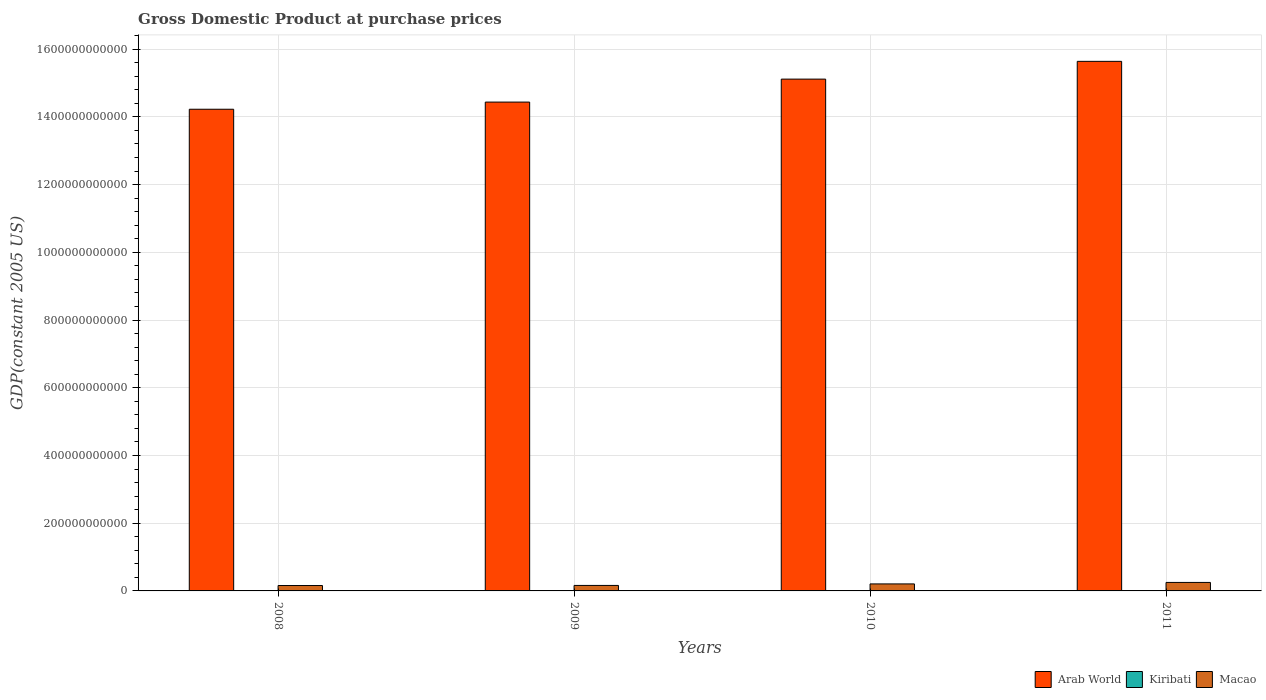How many different coloured bars are there?
Give a very brief answer. 3. Are the number of bars per tick equal to the number of legend labels?
Your response must be concise. Yes. How many bars are there on the 3rd tick from the left?
Your response must be concise. 3. How many bars are there on the 3rd tick from the right?
Your answer should be very brief. 3. What is the label of the 4th group of bars from the left?
Offer a very short reply. 2011. In how many cases, is the number of bars for a given year not equal to the number of legend labels?
Provide a succinct answer. 0. What is the GDP at purchase prices in Kiribati in 2009?
Give a very brief answer. 1.11e+08. Across all years, what is the maximum GDP at purchase prices in Kiribati?
Keep it short and to the point. 1.14e+08. Across all years, what is the minimum GDP at purchase prices in Arab World?
Give a very brief answer. 1.42e+12. In which year was the GDP at purchase prices in Arab World maximum?
Make the answer very short. 2011. What is the total GDP at purchase prices in Arab World in the graph?
Offer a terse response. 5.94e+12. What is the difference between the GDP at purchase prices in Macao in 2009 and that in 2011?
Your response must be concise. -8.87e+09. What is the difference between the GDP at purchase prices in Kiribati in 2011 and the GDP at purchase prices in Arab World in 2008?
Provide a short and direct response. -1.42e+12. What is the average GDP at purchase prices in Kiribati per year?
Give a very brief answer. 1.12e+08. In the year 2008, what is the difference between the GDP at purchase prices in Kiribati and GDP at purchase prices in Macao?
Provide a succinct answer. -1.58e+1. What is the ratio of the GDP at purchase prices in Kiribati in 2010 to that in 2011?
Your response must be concise. 0.97. Is the GDP at purchase prices in Kiribati in 2008 less than that in 2009?
Offer a very short reply. No. What is the difference between the highest and the second highest GDP at purchase prices in Arab World?
Offer a terse response. 5.24e+1. What is the difference between the highest and the lowest GDP at purchase prices in Arab World?
Your answer should be very brief. 1.41e+11. In how many years, is the GDP at purchase prices in Kiribati greater than the average GDP at purchase prices in Kiribati taken over all years?
Your answer should be very brief. 2. What does the 2nd bar from the left in 2010 represents?
Offer a very short reply. Kiribati. What does the 1st bar from the right in 2011 represents?
Offer a very short reply. Macao. Is it the case that in every year, the sum of the GDP at purchase prices in Arab World and GDP at purchase prices in Kiribati is greater than the GDP at purchase prices in Macao?
Give a very brief answer. Yes. How many bars are there?
Your answer should be very brief. 12. What is the difference between two consecutive major ticks on the Y-axis?
Provide a short and direct response. 2.00e+11. Are the values on the major ticks of Y-axis written in scientific E-notation?
Your response must be concise. No. Does the graph contain any zero values?
Make the answer very short. No. Does the graph contain grids?
Ensure brevity in your answer.  Yes. Where does the legend appear in the graph?
Your answer should be compact. Bottom right. How many legend labels are there?
Make the answer very short. 3. What is the title of the graph?
Your answer should be compact. Gross Domestic Product at purchase prices. What is the label or title of the Y-axis?
Make the answer very short. GDP(constant 2005 US). What is the GDP(constant 2005 US) of Arab World in 2008?
Provide a succinct answer. 1.42e+12. What is the GDP(constant 2005 US) of Kiribati in 2008?
Ensure brevity in your answer.  1.12e+08. What is the GDP(constant 2005 US) in Macao in 2008?
Make the answer very short. 1.59e+1. What is the GDP(constant 2005 US) in Arab World in 2009?
Keep it short and to the point. 1.44e+12. What is the GDP(constant 2005 US) of Kiribati in 2009?
Make the answer very short. 1.11e+08. What is the GDP(constant 2005 US) of Macao in 2009?
Give a very brief answer. 1.62e+1. What is the GDP(constant 2005 US) in Arab World in 2010?
Your answer should be very brief. 1.51e+12. What is the GDP(constant 2005 US) in Kiribati in 2010?
Your response must be concise. 1.11e+08. What is the GDP(constant 2005 US) in Macao in 2010?
Make the answer very short. 2.07e+1. What is the GDP(constant 2005 US) of Arab World in 2011?
Provide a succinct answer. 1.56e+12. What is the GDP(constant 2005 US) in Kiribati in 2011?
Your answer should be compact. 1.14e+08. What is the GDP(constant 2005 US) in Macao in 2011?
Your answer should be very brief. 2.51e+1. Across all years, what is the maximum GDP(constant 2005 US) in Arab World?
Offer a terse response. 1.56e+12. Across all years, what is the maximum GDP(constant 2005 US) in Kiribati?
Make the answer very short. 1.14e+08. Across all years, what is the maximum GDP(constant 2005 US) in Macao?
Provide a short and direct response. 2.51e+1. Across all years, what is the minimum GDP(constant 2005 US) in Arab World?
Make the answer very short. 1.42e+12. Across all years, what is the minimum GDP(constant 2005 US) of Kiribati?
Provide a short and direct response. 1.11e+08. Across all years, what is the minimum GDP(constant 2005 US) in Macao?
Ensure brevity in your answer.  1.59e+1. What is the total GDP(constant 2005 US) of Arab World in the graph?
Provide a short and direct response. 5.94e+12. What is the total GDP(constant 2005 US) in Kiribati in the graph?
Provide a succinct answer. 4.48e+08. What is the total GDP(constant 2005 US) of Macao in the graph?
Make the answer very short. 7.79e+1. What is the difference between the GDP(constant 2005 US) in Arab World in 2008 and that in 2009?
Ensure brevity in your answer.  -2.11e+1. What is the difference between the GDP(constant 2005 US) of Kiribati in 2008 and that in 2009?
Your answer should be very brief. 7.45e+05. What is the difference between the GDP(constant 2005 US) of Macao in 2008 and that in 2009?
Offer a terse response. -2.73e+08. What is the difference between the GDP(constant 2005 US) in Arab World in 2008 and that in 2010?
Make the answer very short. -8.90e+1. What is the difference between the GDP(constant 2005 US) in Kiribati in 2008 and that in 2010?
Make the answer very short. 1.30e+06. What is the difference between the GDP(constant 2005 US) of Macao in 2008 and that in 2010?
Ensure brevity in your answer.  -4.73e+09. What is the difference between the GDP(constant 2005 US) in Arab World in 2008 and that in 2011?
Your response must be concise. -1.41e+11. What is the difference between the GDP(constant 2005 US) in Kiribati in 2008 and that in 2011?
Your response must be concise. -1.73e+06. What is the difference between the GDP(constant 2005 US) of Macao in 2008 and that in 2011?
Make the answer very short. -9.14e+09. What is the difference between the GDP(constant 2005 US) in Arab World in 2009 and that in 2010?
Provide a short and direct response. -6.78e+1. What is the difference between the GDP(constant 2005 US) in Kiribati in 2009 and that in 2010?
Your answer should be compact. 5.57e+05. What is the difference between the GDP(constant 2005 US) of Macao in 2009 and that in 2010?
Give a very brief answer. -4.46e+09. What is the difference between the GDP(constant 2005 US) in Arab World in 2009 and that in 2011?
Keep it short and to the point. -1.20e+11. What is the difference between the GDP(constant 2005 US) in Kiribati in 2009 and that in 2011?
Provide a short and direct response. -2.48e+06. What is the difference between the GDP(constant 2005 US) of Macao in 2009 and that in 2011?
Offer a very short reply. -8.87e+09. What is the difference between the GDP(constant 2005 US) of Arab World in 2010 and that in 2011?
Your response must be concise. -5.24e+1. What is the difference between the GDP(constant 2005 US) in Kiribati in 2010 and that in 2011?
Ensure brevity in your answer.  -3.03e+06. What is the difference between the GDP(constant 2005 US) in Macao in 2010 and that in 2011?
Make the answer very short. -4.40e+09. What is the difference between the GDP(constant 2005 US) of Arab World in 2008 and the GDP(constant 2005 US) of Kiribati in 2009?
Keep it short and to the point. 1.42e+12. What is the difference between the GDP(constant 2005 US) in Arab World in 2008 and the GDP(constant 2005 US) in Macao in 2009?
Your response must be concise. 1.41e+12. What is the difference between the GDP(constant 2005 US) of Kiribati in 2008 and the GDP(constant 2005 US) of Macao in 2009?
Provide a short and direct response. -1.61e+1. What is the difference between the GDP(constant 2005 US) in Arab World in 2008 and the GDP(constant 2005 US) in Kiribati in 2010?
Your answer should be compact. 1.42e+12. What is the difference between the GDP(constant 2005 US) of Arab World in 2008 and the GDP(constant 2005 US) of Macao in 2010?
Your response must be concise. 1.40e+12. What is the difference between the GDP(constant 2005 US) of Kiribati in 2008 and the GDP(constant 2005 US) of Macao in 2010?
Your answer should be compact. -2.06e+1. What is the difference between the GDP(constant 2005 US) in Arab World in 2008 and the GDP(constant 2005 US) in Kiribati in 2011?
Ensure brevity in your answer.  1.42e+12. What is the difference between the GDP(constant 2005 US) of Arab World in 2008 and the GDP(constant 2005 US) of Macao in 2011?
Provide a succinct answer. 1.40e+12. What is the difference between the GDP(constant 2005 US) of Kiribati in 2008 and the GDP(constant 2005 US) of Macao in 2011?
Provide a short and direct response. -2.50e+1. What is the difference between the GDP(constant 2005 US) in Arab World in 2009 and the GDP(constant 2005 US) in Kiribati in 2010?
Provide a succinct answer. 1.44e+12. What is the difference between the GDP(constant 2005 US) in Arab World in 2009 and the GDP(constant 2005 US) in Macao in 2010?
Your answer should be very brief. 1.42e+12. What is the difference between the GDP(constant 2005 US) in Kiribati in 2009 and the GDP(constant 2005 US) in Macao in 2010?
Ensure brevity in your answer.  -2.06e+1. What is the difference between the GDP(constant 2005 US) in Arab World in 2009 and the GDP(constant 2005 US) in Kiribati in 2011?
Your answer should be compact. 1.44e+12. What is the difference between the GDP(constant 2005 US) of Arab World in 2009 and the GDP(constant 2005 US) of Macao in 2011?
Keep it short and to the point. 1.42e+12. What is the difference between the GDP(constant 2005 US) of Kiribati in 2009 and the GDP(constant 2005 US) of Macao in 2011?
Keep it short and to the point. -2.50e+1. What is the difference between the GDP(constant 2005 US) of Arab World in 2010 and the GDP(constant 2005 US) of Kiribati in 2011?
Ensure brevity in your answer.  1.51e+12. What is the difference between the GDP(constant 2005 US) in Arab World in 2010 and the GDP(constant 2005 US) in Macao in 2011?
Offer a terse response. 1.49e+12. What is the difference between the GDP(constant 2005 US) in Kiribati in 2010 and the GDP(constant 2005 US) in Macao in 2011?
Give a very brief answer. -2.50e+1. What is the average GDP(constant 2005 US) of Arab World per year?
Give a very brief answer. 1.49e+12. What is the average GDP(constant 2005 US) in Kiribati per year?
Make the answer very short. 1.12e+08. What is the average GDP(constant 2005 US) in Macao per year?
Give a very brief answer. 1.95e+1. In the year 2008, what is the difference between the GDP(constant 2005 US) in Arab World and GDP(constant 2005 US) in Kiribati?
Give a very brief answer. 1.42e+12. In the year 2008, what is the difference between the GDP(constant 2005 US) in Arab World and GDP(constant 2005 US) in Macao?
Ensure brevity in your answer.  1.41e+12. In the year 2008, what is the difference between the GDP(constant 2005 US) in Kiribati and GDP(constant 2005 US) in Macao?
Provide a succinct answer. -1.58e+1. In the year 2009, what is the difference between the GDP(constant 2005 US) in Arab World and GDP(constant 2005 US) in Kiribati?
Your answer should be very brief. 1.44e+12. In the year 2009, what is the difference between the GDP(constant 2005 US) in Arab World and GDP(constant 2005 US) in Macao?
Offer a very short reply. 1.43e+12. In the year 2009, what is the difference between the GDP(constant 2005 US) in Kiribati and GDP(constant 2005 US) in Macao?
Offer a very short reply. -1.61e+1. In the year 2010, what is the difference between the GDP(constant 2005 US) in Arab World and GDP(constant 2005 US) in Kiribati?
Your response must be concise. 1.51e+12. In the year 2010, what is the difference between the GDP(constant 2005 US) in Arab World and GDP(constant 2005 US) in Macao?
Provide a succinct answer. 1.49e+12. In the year 2010, what is the difference between the GDP(constant 2005 US) in Kiribati and GDP(constant 2005 US) in Macao?
Keep it short and to the point. -2.06e+1. In the year 2011, what is the difference between the GDP(constant 2005 US) in Arab World and GDP(constant 2005 US) in Kiribati?
Provide a succinct answer. 1.56e+12. In the year 2011, what is the difference between the GDP(constant 2005 US) in Arab World and GDP(constant 2005 US) in Macao?
Your response must be concise. 1.54e+12. In the year 2011, what is the difference between the GDP(constant 2005 US) in Kiribati and GDP(constant 2005 US) in Macao?
Give a very brief answer. -2.50e+1. What is the ratio of the GDP(constant 2005 US) in Arab World in 2008 to that in 2009?
Ensure brevity in your answer.  0.99. What is the ratio of the GDP(constant 2005 US) of Kiribati in 2008 to that in 2009?
Provide a succinct answer. 1.01. What is the ratio of the GDP(constant 2005 US) in Macao in 2008 to that in 2009?
Make the answer very short. 0.98. What is the ratio of the GDP(constant 2005 US) of Arab World in 2008 to that in 2010?
Provide a succinct answer. 0.94. What is the ratio of the GDP(constant 2005 US) of Kiribati in 2008 to that in 2010?
Offer a very short reply. 1.01. What is the ratio of the GDP(constant 2005 US) of Macao in 2008 to that in 2010?
Make the answer very short. 0.77. What is the ratio of the GDP(constant 2005 US) in Arab World in 2008 to that in 2011?
Make the answer very short. 0.91. What is the ratio of the GDP(constant 2005 US) of Macao in 2008 to that in 2011?
Offer a very short reply. 0.64. What is the ratio of the GDP(constant 2005 US) in Arab World in 2009 to that in 2010?
Ensure brevity in your answer.  0.96. What is the ratio of the GDP(constant 2005 US) in Kiribati in 2009 to that in 2010?
Make the answer very short. 1. What is the ratio of the GDP(constant 2005 US) in Macao in 2009 to that in 2010?
Ensure brevity in your answer.  0.78. What is the ratio of the GDP(constant 2005 US) of Arab World in 2009 to that in 2011?
Provide a short and direct response. 0.92. What is the ratio of the GDP(constant 2005 US) of Kiribati in 2009 to that in 2011?
Your answer should be compact. 0.98. What is the ratio of the GDP(constant 2005 US) of Macao in 2009 to that in 2011?
Give a very brief answer. 0.65. What is the ratio of the GDP(constant 2005 US) of Arab World in 2010 to that in 2011?
Keep it short and to the point. 0.97. What is the ratio of the GDP(constant 2005 US) in Kiribati in 2010 to that in 2011?
Make the answer very short. 0.97. What is the ratio of the GDP(constant 2005 US) in Macao in 2010 to that in 2011?
Your answer should be compact. 0.82. What is the difference between the highest and the second highest GDP(constant 2005 US) in Arab World?
Give a very brief answer. 5.24e+1. What is the difference between the highest and the second highest GDP(constant 2005 US) of Kiribati?
Ensure brevity in your answer.  1.73e+06. What is the difference between the highest and the second highest GDP(constant 2005 US) in Macao?
Provide a short and direct response. 4.40e+09. What is the difference between the highest and the lowest GDP(constant 2005 US) in Arab World?
Make the answer very short. 1.41e+11. What is the difference between the highest and the lowest GDP(constant 2005 US) of Kiribati?
Provide a succinct answer. 3.03e+06. What is the difference between the highest and the lowest GDP(constant 2005 US) of Macao?
Ensure brevity in your answer.  9.14e+09. 